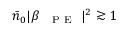<formula> <loc_0><loc_0><loc_500><loc_500>\bar { n } _ { 0 } | \beta _ { { P E } } | ^ { 2 } \gtrsim 1</formula> 